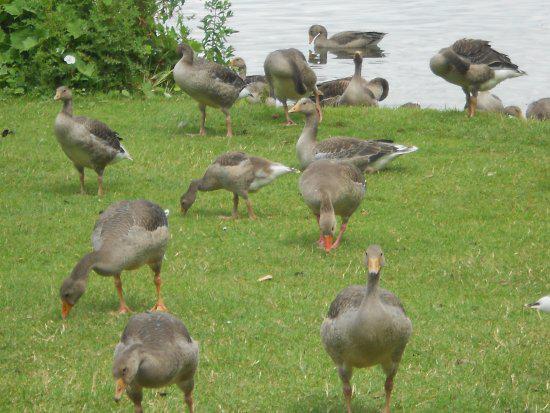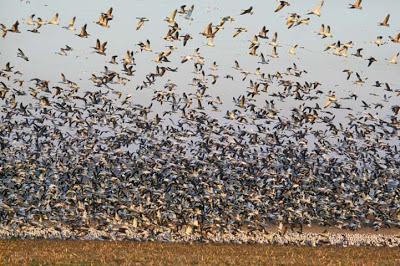The first image is the image on the left, the second image is the image on the right. Considering the images on both sides, is "There are more birds in the right image than in the left." valid? Answer yes or no. Yes. 